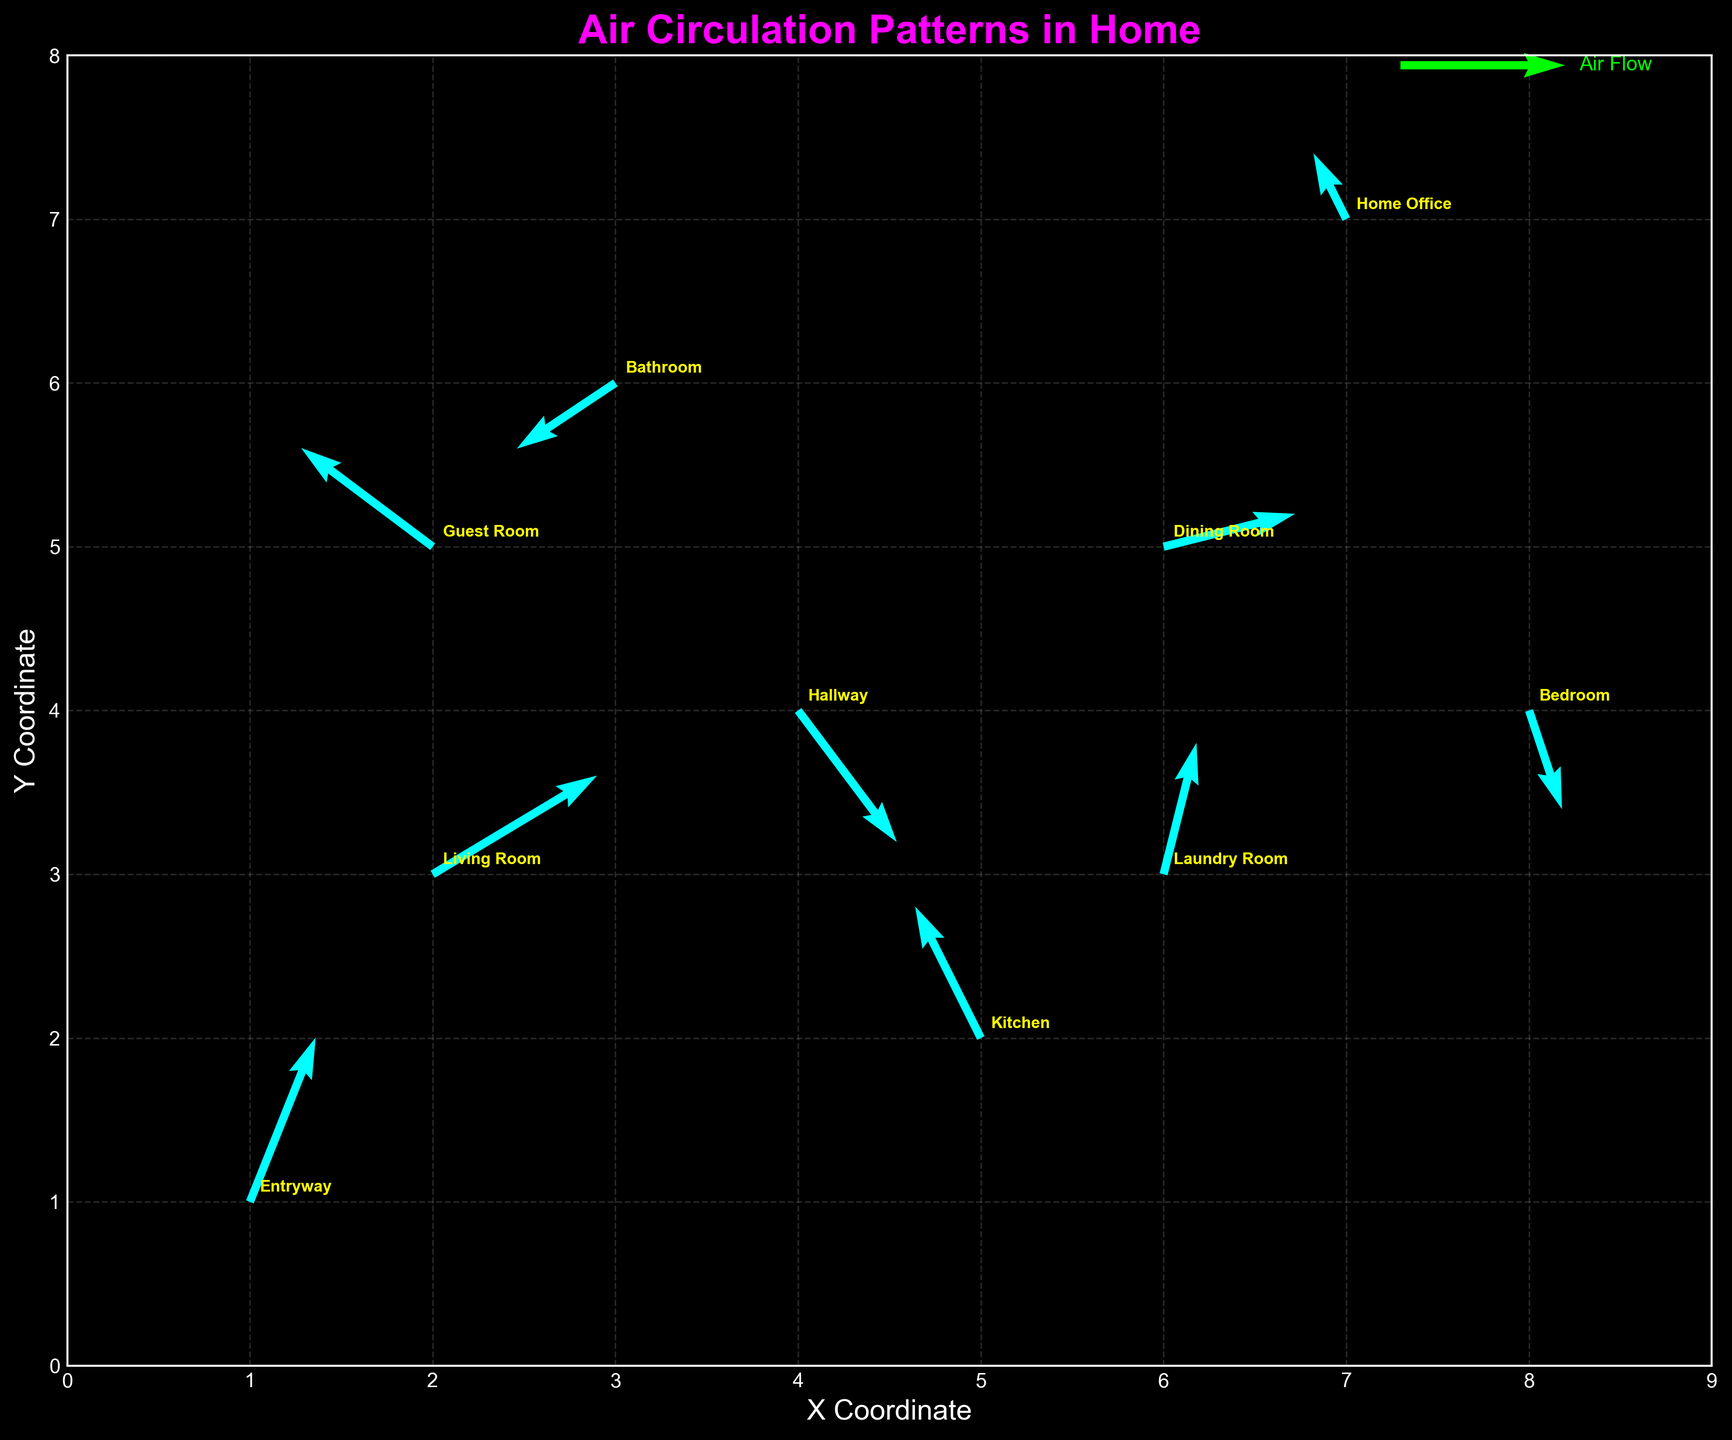How many rooms are represented in the figure? The figure labels 10 rooms, each represented by annotated text on the quiver plot. Count the number of unique room names noted in the plot.
Answer: 10 What is the x and y coordinate range shown in the figure? The plot's axes are labeled from 0 to 9 on the x-axis and from 0 to 8 on the y-axis, which are the displayed ranges.
Answer: 0 to 9 (x-axis), 0 to 8 (y-axis) Which room has the largest upward air circulation (v component)? Check the v values corresponding to each room and identify the largest positive value. The room with coordinates (1,1) has a v value of 0.5.
Answer: Entryway Is the air flow direction in the Kitchen towards the left or right? The quiver arrow for the Kitchen shows an x component (u value) of -0.2, indicating a leftward direction.
Answer: Left What is the net air flow direction in the Home Office? Check the u and v components for the Home Office. The values are (-0.1, 0.2), which corresponds to a slight left and upwards direction.
Answer: Slightly left and upwards What are the x and y components of the air flow in the Hallway? Locate the Hallway on the plot and read off the u and v values shown. For Hallway, these values are (0.3, -0.4).
Answer: 0.3 (x component), -0.4 (y component) Which room has the strongest diagonal air flow (combination of both u and v components in magnitude)? Compute the magnitude √(u^2 + v^2) for each room and compare. Entryway has the largest magnitude √(0.2^2 + 0.5^2) ≈ 0.5385.
Answer: Entryway Compare the air flow vectors between the Living Room and the Dining Room. Which room has air flow more to the right? The u values for Living Room (0.5) and Dining Room (0.4) indicate both are to the right, but 0.5 is higher.
Answer: Living Room What room has the least amount of air circulation (smallest magnitude of the vector)? Calculate the magnitude √(u^2 + v^2) for each room; the smallest is Home Office with magnitude √((-0.1)^2 + 0.2^2) ≈ 0.2236.
Answer: Home Office 